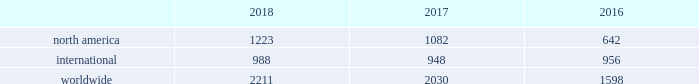32 | bhge 2018 form 10-k baker hughes rig count the baker hughes rig counts are an important business barometer for the drilling industry and its suppliers .
When drilling rigs are active they consume products and services produced by the oil service industry .
Rig count trends are driven by the exploration and development spending by oil and natural gas companies , which in turn is influenced by current and future price expectations for oil and natural gas .
The counts may reflect the relative strength and stability of energy prices and overall market activity , however , these counts should not be solely relied on as other specific and pervasive conditions may exist that affect overall energy prices and market activity .
We have been providing rig counts to the public since 1944 .
We gather all relevant data through our field service personnel , who obtain the necessary data from routine visits to the various rigs , customers , contractors and other outside sources as necessary .
We base the classification of a well as either oil or natural gas primarily upon filings made by operators in the relevant jurisdiction .
This data is then compiled and distributed to various wire services and trade associations and is published on our website .
We believe the counting process and resulting data is reliable , however , it is subject to our ability to obtain accurate and timely information .
Rig counts are compiled weekly for the u.s .
And canada and monthly for all international rigs .
Published international rig counts do not include rigs drilling in certain locations , such as russia , the caspian region and onshore china because this information is not readily available .
Rigs in the u.s .
And canada are counted as active if , on the day the count is taken , the well being drilled has been started but drilling has not been completed and the well is anticipated to be of sufficient depth to be a potential consumer of our drill bits .
In international areas , rigs are counted on a weekly basis and deemed active if drilling activities occurred during the majority of the week .
The weekly results are then averaged for the month and published accordingly .
The rig count does not include rigs that are in transit from one location to another , rigging up , being used in non-drilling activities including production testing , completion and workover , and are not expected to be significant consumers of drill bits .
The rig counts are summarized in the table below as averages for each of the periods indicated. .
2018 compared to 2017 overall the rig count was 2211 in 2018 , an increase of 9% ( 9 % ) as compared to 2017 due primarily to north american activity .
The rig count in north america increased 13% ( 13 % ) in 2018 compared to 2017 .
Internationally , the rig count increased 4% ( 4 % ) in 2018 as compared to the same period last year .
Within north america , the increase was primarily driven by the u.s .
Rig count , which was up 18% ( 18 % ) on average versus 2017 , partially offset with a decrease in the canadian rig count , which was down 8% ( 8 % ) on average .
Internationally , the improvement in the rig count was driven primarily by increases in the africa region of 18% ( 18 % ) , the asia-pacific region and latin america region , were also up by 9% ( 9 % ) and 3% ( 3 % ) , respectively , partially offset by the europe region , which was down 8% ( 8 % ) .
2017 compared to 2016 overall the rig count was 2030 in 2017 , an increase of 27% ( 27 % ) as compared to 2016 due primarily to north american activity .
The rig count in north america increased 69% ( 69 % ) in 2017 compared to 2016 .
Internationally , the rig count decreased 1% ( 1 % ) in 2017 as compared to the same period last year .
Within north america , the increase was primarily driven by the land rig count , which was up 72% ( 72 % ) , partially offset by a decrease in the offshore rig count of 16% ( 16 % ) .
Internationally , the rig count decrease was driven primarily by decreases in latin america of 7% ( 7 % ) , the europe region and africa region , which were down by 4% ( 4 % ) and 2% ( 2 % ) , respectively , partially offset by the asia-pacific region , which was up 8%. .
What portion of total rig count is in north america in 2017? 
Computations: (1082 / 2030)
Answer: 0.533. 